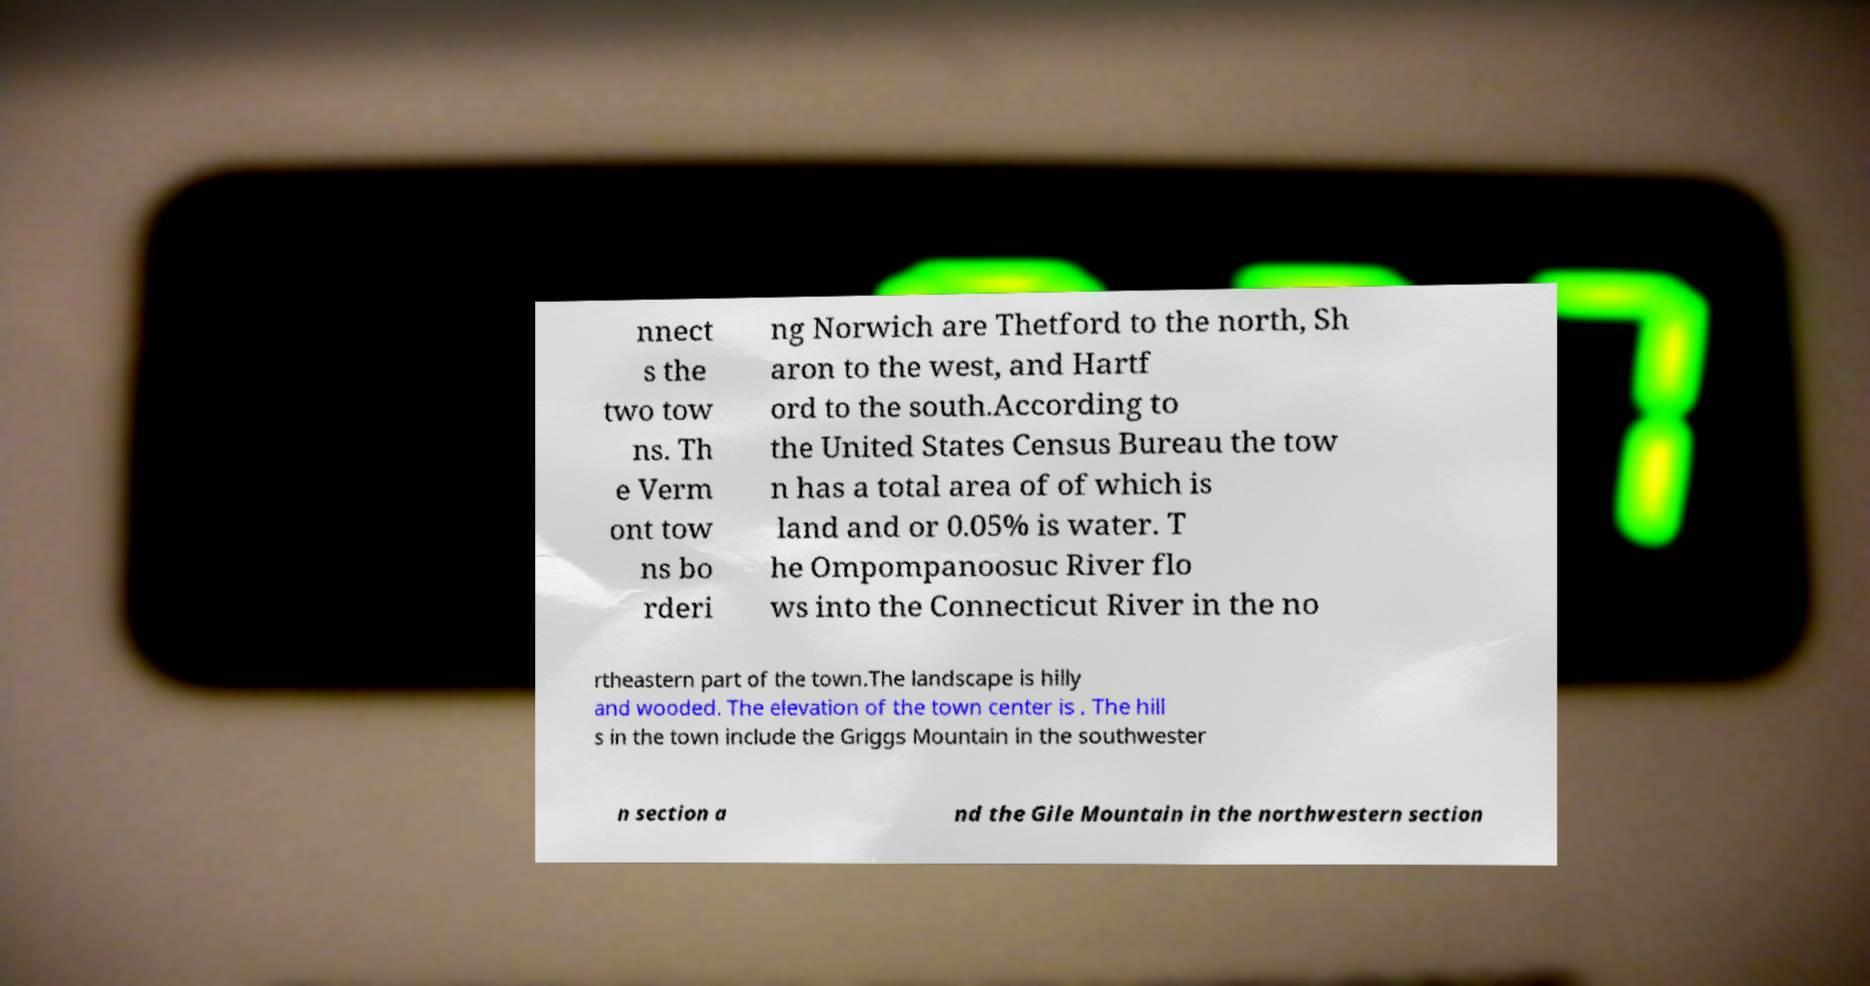I need the written content from this picture converted into text. Can you do that? nnect s the two tow ns. Th e Verm ont tow ns bo rderi ng Norwich are Thetford to the north, Sh aron to the west, and Hartf ord to the south.According to the United States Census Bureau the tow n has a total area of of which is land and or 0.05% is water. T he Ompompanoosuc River flo ws into the Connecticut River in the no rtheastern part of the town.The landscape is hilly and wooded. The elevation of the town center is . The hill s in the town include the Griggs Mountain in the southwester n section a nd the Gile Mountain in the northwestern section 